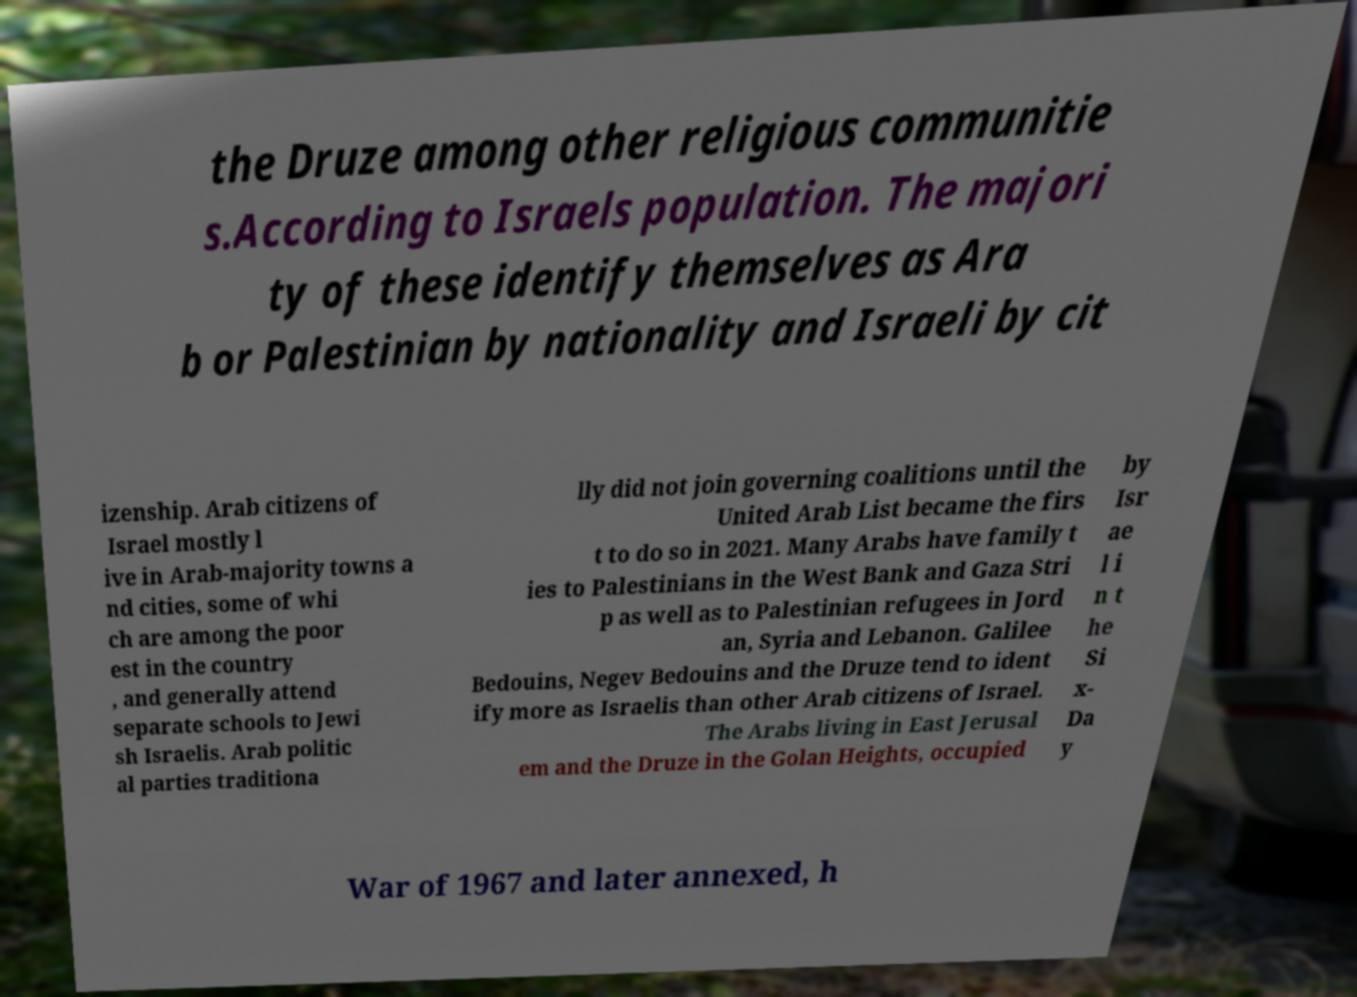There's text embedded in this image that I need extracted. Can you transcribe it verbatim? the Druze among other religious communitie s.According to Israels population. The majori ty of these identify themselves as Ara b or Palestinian by nationality and Israeli by cit izenship. Arab citizens of Israel mostly l ive in Arab-majority towns a nd cities, some of whi ch are among the poor est in the country , and generally attend separate schools to Jewi sh Israelis. Arab politic al parties traditiona lly did not join governing coalitions until the United Arab List became the firs t to do so in 2021. Many Arabs have family t ies to Palestinians in the West Bank and Gaza Stri p as well as to Palestinian refugees in Jord an, Syria and Lebanon. Galilee Bedouins, Negev Bedouins and the Druze tend to ident ify more as Israelis than other Arab citizens of Israel. The Arabs living in East Jerusal em and the Druze in the Golan Heights, occupied by Isr ae l i n t he Si x- Da y War of 1967 and later annexed, h 